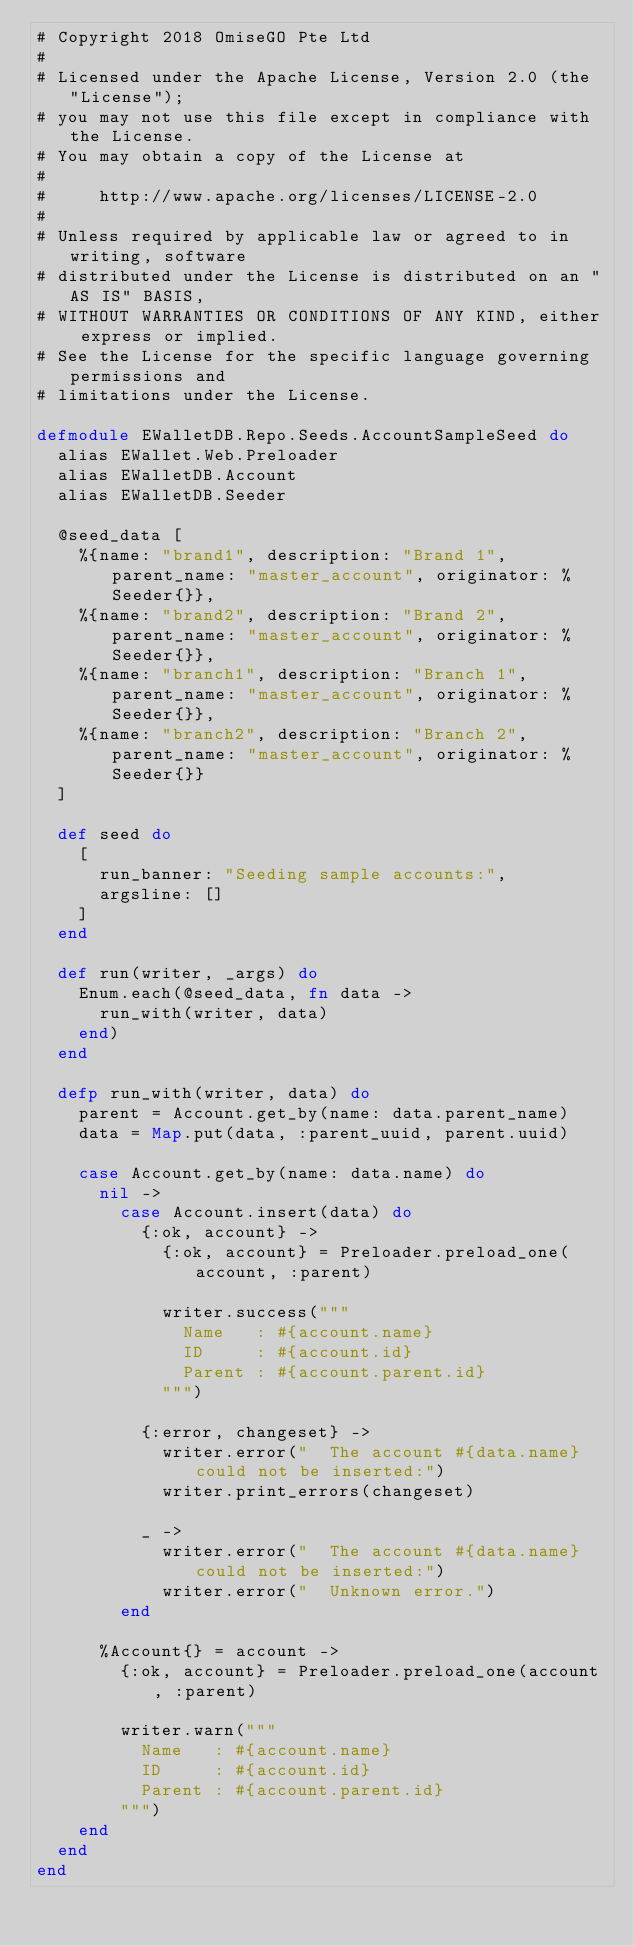Convert code to text. <code><loc_0><loc_0><loc_500><loc_500><_Elixir_># Copyright 2018 OmiseGO Pte Ltd
#
# Licensed under the Apache License, Version 2.0 (the "License");
# you may not use this file except in compliance with the License.
# You may obtain a copy of the License at
#
#     http://www.apache.org/licenses/LICENSE-2.0
#
# Unless required by applicable law or agreed to in writing, software
# distributed under the License is distributed on an "AS IS" BASIS,
# WITHOUT WARRANTIES OR CONDITIONS OF ANY KIND, either express or implied.
# See the License for the specific language governing permissions and
# limitations under the License.

defmodule EWalletDB.Repo.Seeds.AccountSampleSeed do
  alias EWallet.Web.Preloader
  alias EWalletDB.Account
  alias EWalletDB.Seeder

  @seed_data [
    %{name: "brand1", description: "Brand 1", parent_name: "master_account", originator: %Seeder{}},
    %{name: "brand2", description: "Brand 2", parent_name: "master_account", originator: %Seeder{}},
    %{name: "branch1", description: "Branch 1", parent_name: "master_account", originator: %Seeder{}},
    %{name: "branch2", description: "Branch 2", parent_name: "master_account", originator: %Seeder{}}
  ]

  def seed do
    [
      run_banner: "Seeding sample accounts:",
      argsline: []
    ]
  end

  def run(writer, _args) do
    Enum.each(@seed_data, fn data ->
      run_with(writer, data)
    end)
  end

  defp run_with(writer, data) do
    parent = Account.get_by(name: data.parent_name)
    data = Map.put(data, :parent_uuid, parent.uuid)

    case Account.get_by(name: data.name) do
      nil ->
        case Account.insert(data) do
          {:ok, account} ->
            {:ok, account} = Preloader.preload_one(account, :parent)

            writer.success("""
              Name   : #{account.name}
              ID     : #{account.id}
              Parent : #{account.parent.id}
            """)

          {:error, changeset} ->
            writer.error("  The account #{data.name} could not be inserted:")
            writer.print_errors(changeset)

          _ ->
            writer.error("  The account #{data.name} could not be inserted:")
            writer.error("  Unknown error.")
        end

      %Account{} = account ->
        {:ok, account} = Preloader.preload_one(account, :parent)

        writer.warn("""
          Name   : #{account.name}
          ID     : #{account.id}
          Parent : #{account.parent.id}
        """)
    end
  end
end
</code> 